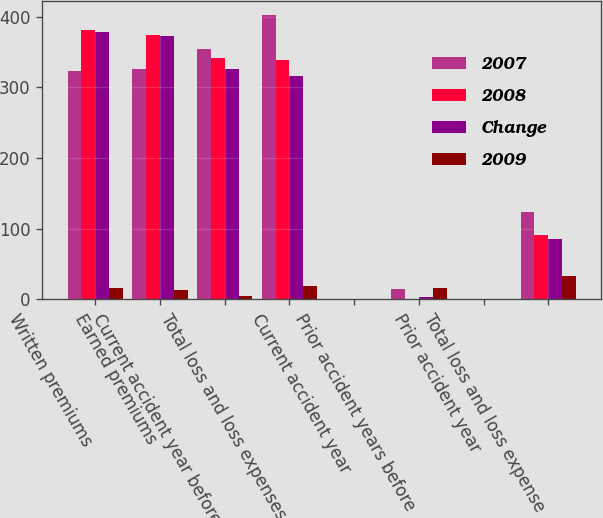Convert chart. <chart><loc_0><loc_0><loc_500><loc_500><stacked_bar_chart><ecel><fcel>Written premiums<fcel>Earned premiums<fcel>Current accident year before<fcel>Total loss and loss expenses<fcel>Current accident year<fcel>Prior accident years before<fcel>Prior accident year<fcel>Total loss and loss expense<nl><fcel>2007<fcel>323<fcel>326<fcel>355<fcel>403<fcel>0<fcel>14.7<fcel>0<fcel>123.5<nl><fcel>2008<fcel>382<fcel>375<fcel>342<fcel>339<fcel>0<fcel>0.7<fcel>0<fcel>90.4<nl><fcel>Change<fcel>378<fcel>373<fcel>326<fcel>316<fcel>0<fcel>2.7<fcel>0<fcel>84.6<nl><fcel>2009<fcel>15.6<fcel>13<fcel>4<fcel>18.9<fcel>0<fcel>15.4<fcel>0<fcel>33.1<nl></chart> 